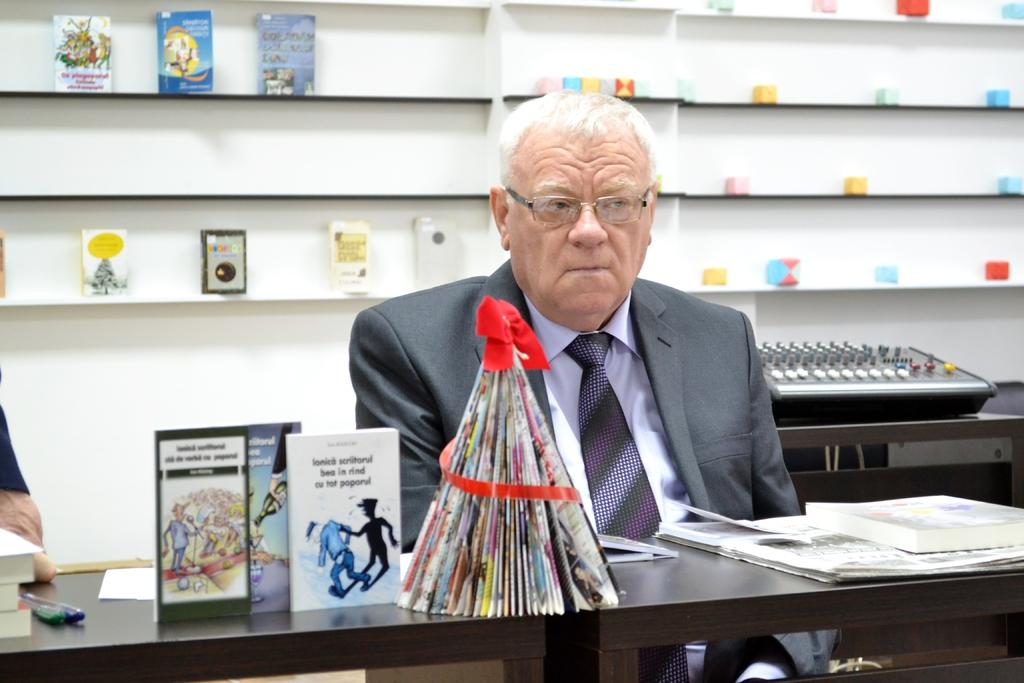What is the man in the image doing? The man is sitting in the image. Can you describe the man's appearance? The man is wearing glasses (specs). What objects are on the table in the image? There are books, pens, and additional items on the table in the image. Are there any books visible in any other part of the image? Yes, there are books visible in the background of the image. What type of dress is the man wearing in the image? The man is not wearing a dress in the image; he is wearing glasses and is likely wearing regular clothing. Can you see a ring on the man's finger in the image? There is no ring visible on the man's finger in the image. 